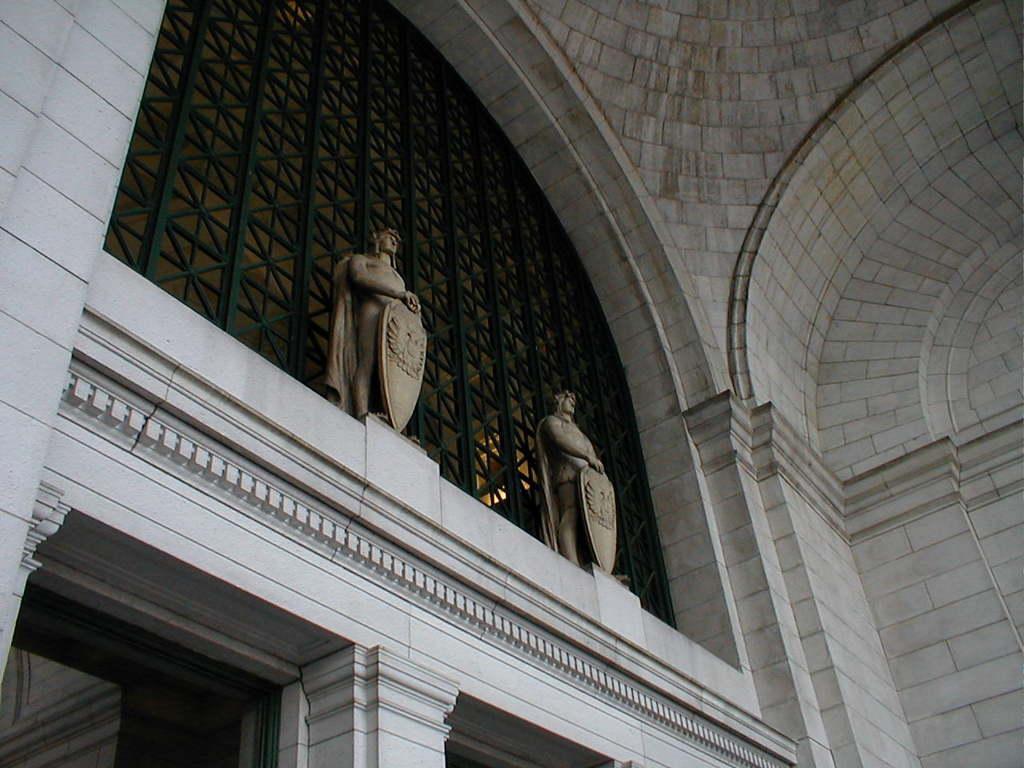Describe this image in one or two sentences. This picture seems to be clicked inside the hall. In the foreground we can see the pillars. In the center we can see the sculptures of the persons holding some objects and standing. In the background we can see the wall, arches, metal rods and some objects. 